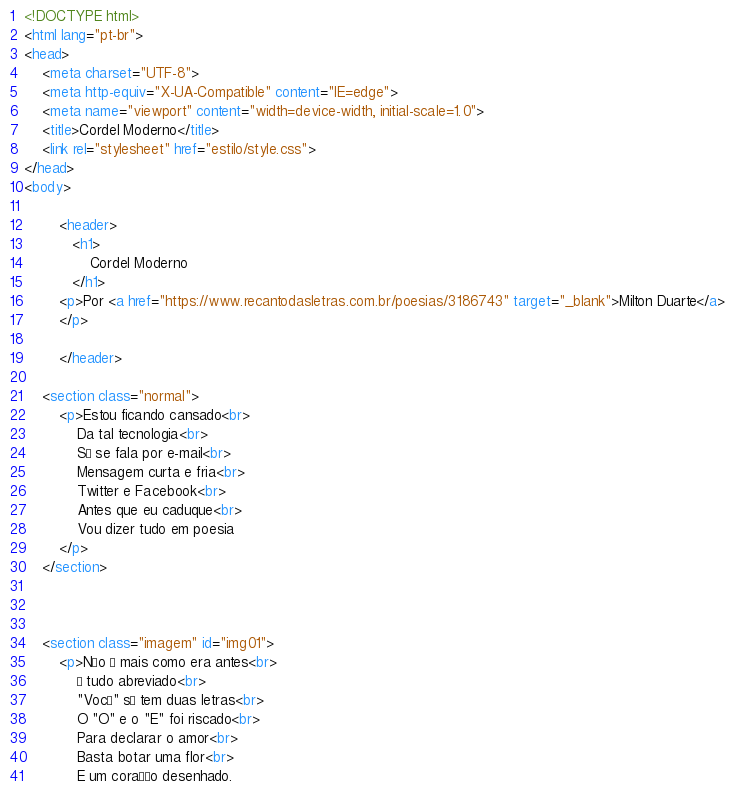Convert code to text. <code><loc_0><loc_0><loc_500><loc_500><_HTML_><!DOCTYPE html>
<html lang="pt-br">
<head>
    <meta charset="UTF-8">
    <meta http-equiv="X-UA-Compatible" content="IE=edge">
    <meta name="viewport" content="width=device-width, initial-scale=1.0">
    <title>Cordel Moderno</title>
    <link rel="stylesheet" href="estilo/style.css">
</head>
<body>
       
        <header>
           <h1>
               Cordel Moderno
           </h1>
        <p>Por <a href="https://www.recantodasletras.com.br/poesias/3186743" target="_blank">Milton Duarte</a> 
        </p> 
        
        </header> 

    <section class="normal">
        <p>Estou ficando cansado<br>
            Da tal tecnologia<br>
            Só se fala por e-mail<br>
            Mensagem curta e fria<br>
            Twitter e Facebook<br>
            Antes que eu caduque<br>
            Vou dizer tudo em poesia
        </p>
    </section>

 

    <section class="imagem" id="img01">
        <p>Não é mais como era antes<br>
            É tudo abreviado<br>
            "Você" só tem duas letras<br>
            O "O" e o "E" foi riscado<br>
            Para declarar o amor<br>
            Basta botar uma flor<br>
            E um coração desenhado.</code> 